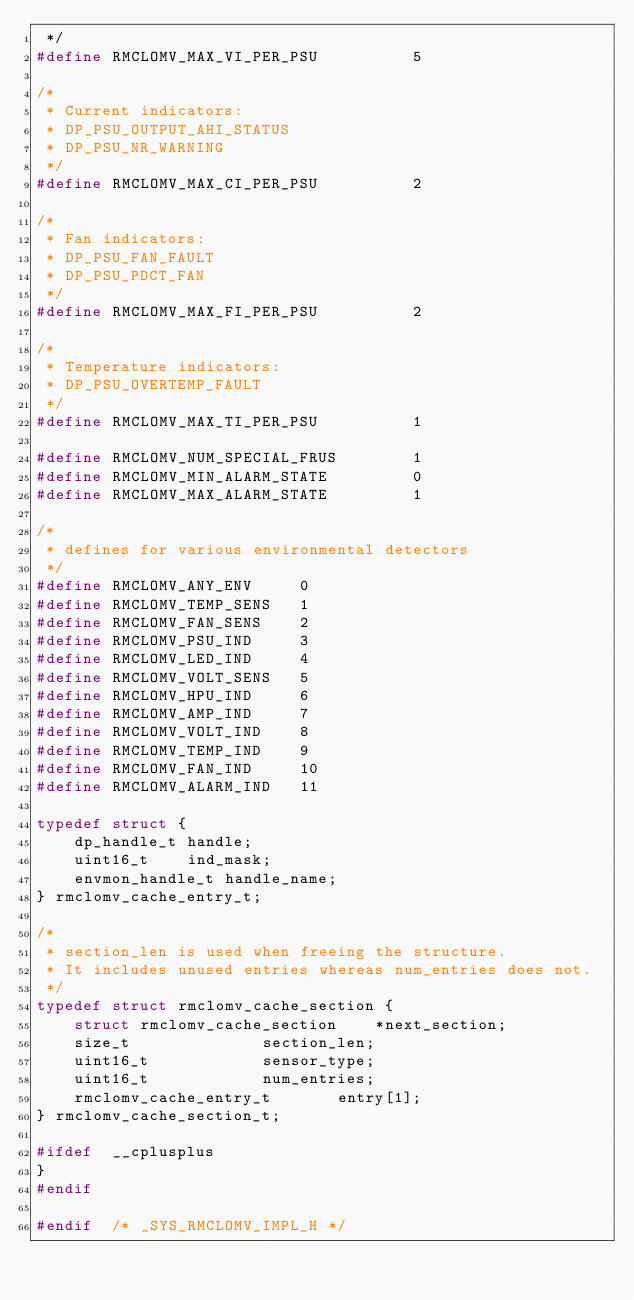Convert code to text. <code><loc_0><loc_0><loc_500><loc_500><_C_> */
#define	RMCLOMV_MAX_VI_PER_PSU			5

/*
 * Current indicators:
 * DP_PSU_OUTPUT_AHI_STATUS
 * DP_PSU_NR_WARNING
 */
#define	RMCLOMV_MAX_CI_PER_PSU			2

/*
 * Fan indicators:
 * DP_PSU_FAN_FAULT
 * DP_PSU_PDCT_FAN
 */
#define	RMCLOMV_MAX_FI_PER_PSU			2

/*
 * Temperature indicators:
 * DP_PSU_OVERTEMP_FAULT
 */
#define	RMCLOMV_MAX_TI_PER_PSU			1

#define	RMCLOMV_NUM_SPECIAL_FRUS		1
#define	RMCLOMV_MIN_ALARM_STATE			0
#define	RMCLOMV_MAX_ALARM_STATE			1

/*
 * defines for various environmental detectors
 */
#define	RMCLOMV_ANY_ENV		0
#define	RMCLOMV_TEMP_SENS	1
#define	RMCLOMV_FAN_SENS	2
#define	RMCLOMV_PSU_IND		3
#define	RMCLOMV_LED_IND		4
#define	RMCLOMV_VOLT_SENS	5
#define	RMCLOMV_HPU_IND		6
#define	RMCLOMV_AMP_IND		7
#define	RMCLOMV_VOLT_IND	8
#define	RMCLOMV_TEMP_IND	9
#define	RMCLOMV_FAN_IND		10
#define	RMCLOMV_ALARM_IND	11

typedef struct {
	dp_handle_t	handle;
	uint16_t	ind_mask;
	envmon_handle_t	handle_name;
} rmclomv_cache_entry_t;

/*
 * section_len is used when freeing the structure.
 * It includes unused entries whereas num_entries does not.
 */
typedef struct rmclomv_cache_section {
	struct rmclomv_cache_section	*next_section;
	size_t				section_len;
	uint16_t			sensor_type;
	uint16_t			num_entries;
	rmclomv_cache_entry_t		entry[1];
} rmclomv_cache_section_t;

#ifdef	__cplusplus
}
#endif

#endif	/* _SYS_RMCLOMV_IMPL_H */
</code> 